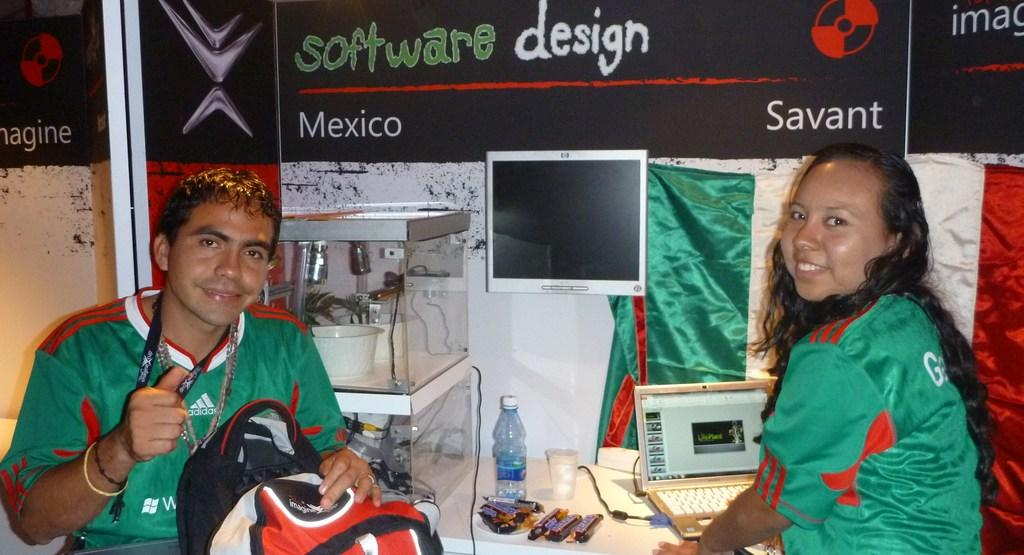<image>
Offer a succinct explanation of the picture presented. A man and woman demonstrate their display entitled Software Design. 